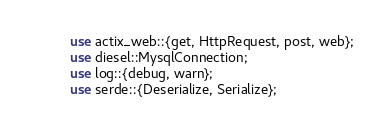Convert code to text. <code><loc_0><loc_0><loc_500><loc_500><_Rust_>use actix_web::{get, HttpRequest, post, web};
use diesel::MysqlConnection;
use log::{debug, warn};
use serde::{Deserialize, Serialize};
</code> 